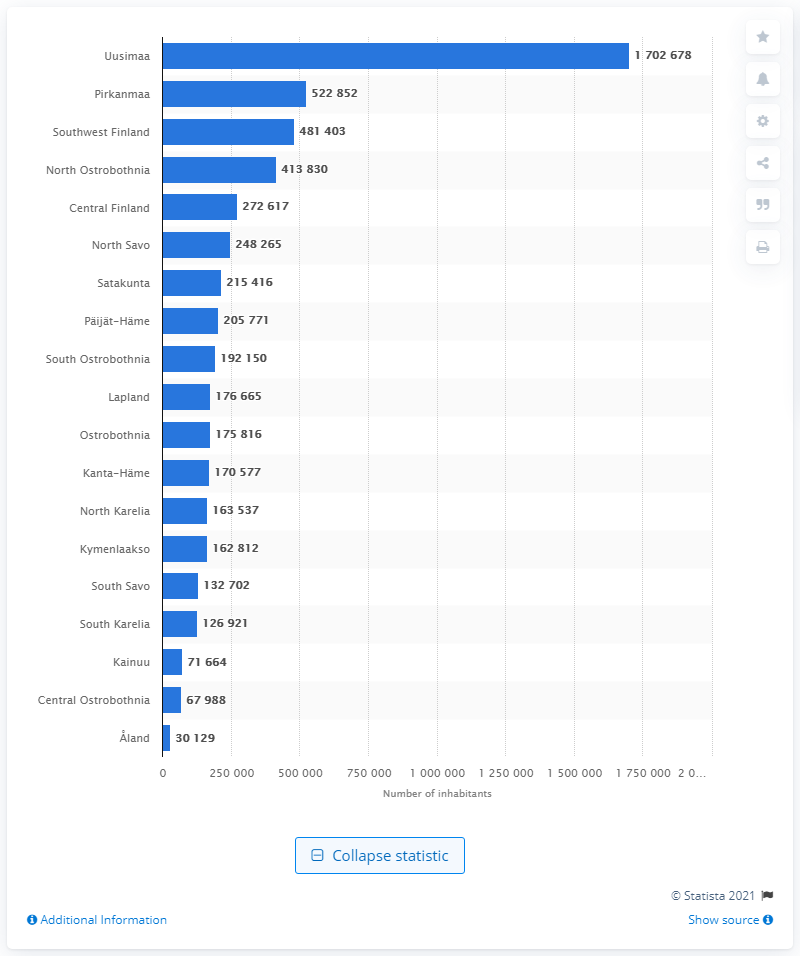Mention a couple of crucial points in this snapshot. Pirkanmaa is the second largest region in terms of population. As of 2022, it is estimated that approximately 1,702,678 people reside in Uusimaa. As of the latest statistics, approximately 522,852 individuals reside in the region of Pirkanmaa. Finland's capital region is Uusimaa. 